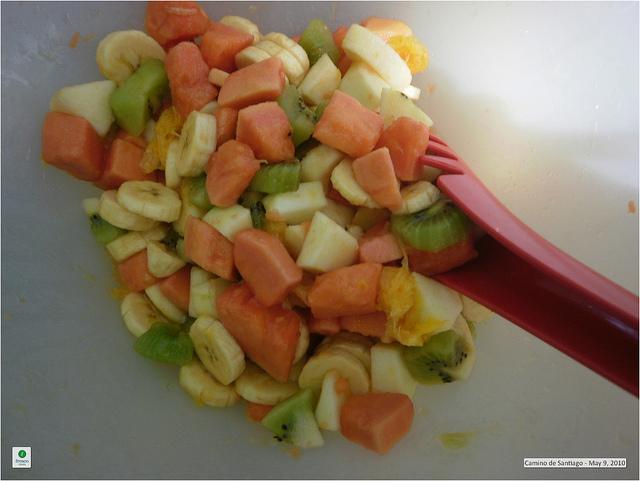What do you call the red utensil?
Short answer required. Spoon. Is there any sweet candy shown?
Concise answer only. No. Is the display of food likable?
Give a very brief answer. Yes. What is in this salad?
Be succinct. Fruit. What is the board called with the vegetables on top?
Concise answer only. Cutting board. What kind of melon is pictured?
Concise answer only. Cantaloupe. What is yellow?
Keep it brief. Banana. What type of Salad is this?
Write a very short answer. Fruit. Does the picture show more than one type of vegetable?
Concise answer only. Yes. What is the red utensil called?
Write a very short answer. Spoon. What is the green stuff on the plate?
Short answer required. Kiwi. Is this fruit whole or sliced?
Give a very brief answer. Sliced. What fruit is on this salad?
Concise answer only. Bananas. Is the bananas ready to eat?
Write a very short answer. Yes. What is the green thing in the bowl?
Be succinct. Kiwi. What is the green vegetable?
Concise answer only. Kiwi. 